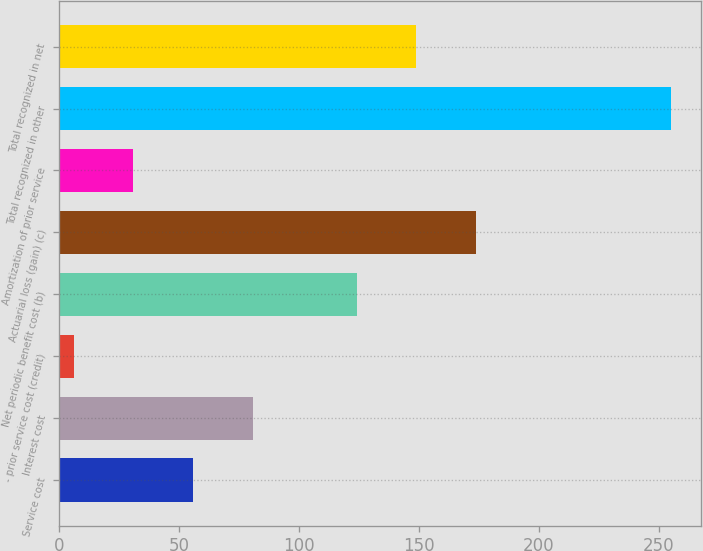<chart> <loc_0><loc_0><loc_500><loc_500><bar_chart><fcel>Service cost<fcel>Interest cost<fcel>- prior service cost (credit)<fcel>Net periodic benefit cost (b)<fcel>Actuarial loss (gain) (c)<fcel>Amortization of prior service<fcel>Total recognized in other<fcel>Total recognized in net<nl><fcel>55.8<fcel>80.7<fcel>6<fcel>124<fcel>173.8<fcel>30.9<fcel>255<fcel>148.9<nl></chart> 